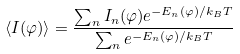<formula> <loc_0><loc_0><loc_500><loc_500>\langle I ( \varphi ) \rangle = \frac { \sum _ { n } I _ { n } ( \varphi ) e ^ { - E _ { n } ( \varphi ) / k _ { B } T } } { \sum _ { n } e ^ { - E _ { n } ( \varphi ) / k _ { B } T } }</formula> 